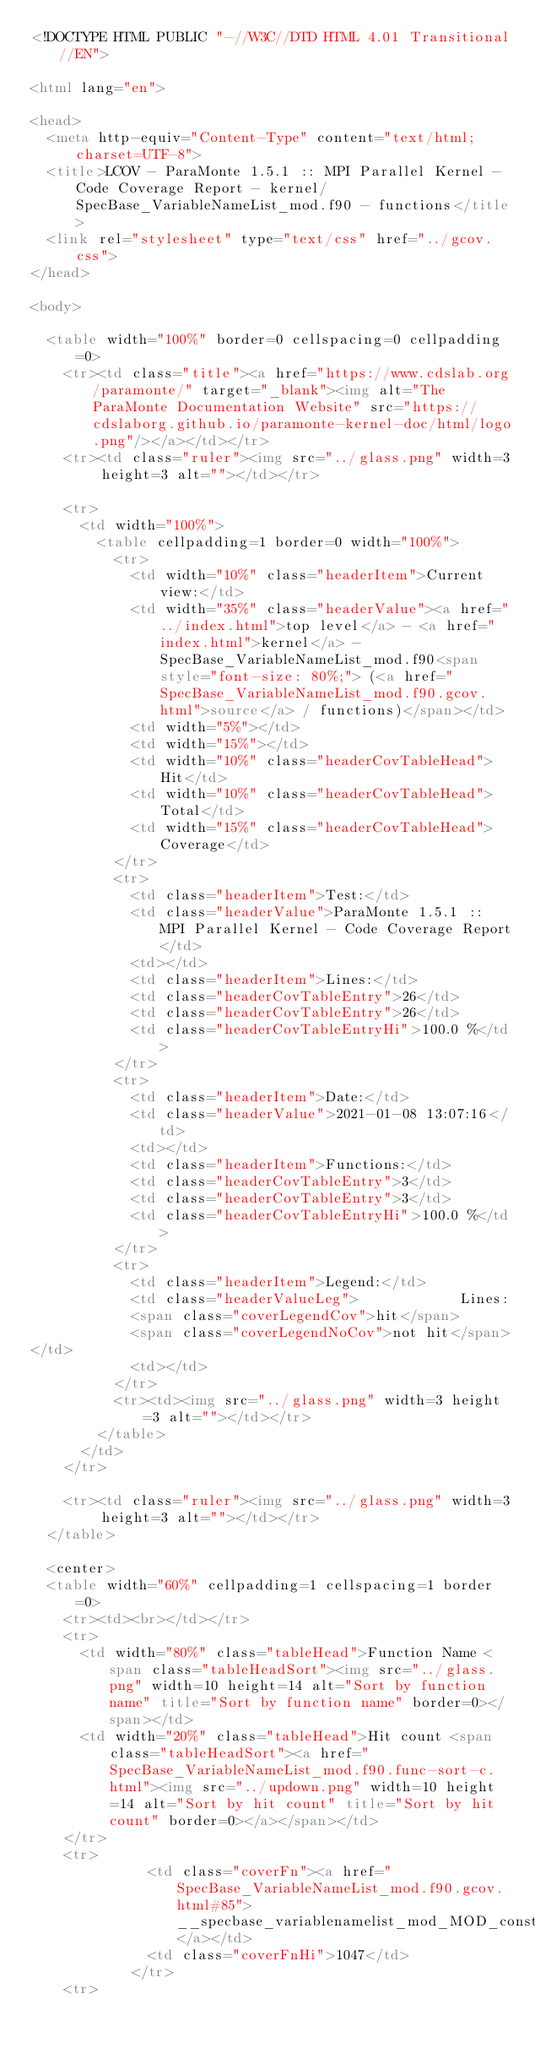<code> <loc_0><loc_0><loc_500><loc_500><_HTML_><!DOCTYPE HTML PUBLIC "-//W3C//DTD HTML 4.01 Transitional//EN">

<html lang="en">

<head>
  <meta http-equiv="Content-Type" content="text/html; charset=UTF-8">
  <title>LCOV - ParaMonte 1.5.1 :: MPI Parallel Kernel - Code Coverage Report - kernel/SpecBase_VariableNameList_mod.f90 - functions</title>
  <link rel="stylesheet" type="text/css" href="../gcov.css">
</head>

<body>

  <table width="100%" border=0 cellspacing=0 cellpadding=0>
    <tr><td class="title"><a href="https://www.cdslab.org/paramonte/" target="_blank"><img alt="The ParaMonte Documentation Website" src="https://cdslaborg.github.io/paramonte-kernel-doc/html/logo.png"/></a></td></tr>
    <tr><td class="ruler"><img src="../glass.png" width=3 height=3 alt=""></td></tr>

    <tr>
      <td width="100%">
        <table cellpadding=1 border=0 width="100%">
          <tr>
            <td width="10%" class="headerItem">Current view:</td>
            <td width="35%" class="headerValue"><a href="../index.html">top level</a> - <a href="index.html">kernel</a> - SpecBase_VariableNameList_mod.f90<span style="font-size: 80%;"> (<a href="SpecBase_VariableNameList_mod.f90.gcov.html">source</a> / functions)</span></td>
            <td width="5%"></td>
            <td width="15%"></td>
            <td width="10%" class="headerCovTableHead">Hit</td>
            <td width="10%" class="headerCovTableHead">Total</td>
            <td width="15%" class="headerCovTableHead">Coverage</td>
          </tr>
          <tr>
            <td class="headerItem">Test:</td>
            <td class="headerValue">ParaMonte 1.5.1 :: MPI Parallel Kernel - Code Coverage Report</td>
            <td></td>
            <td class="headerItem">Lines:</td>
            <td class="headerCovTableEntry">26</td>
            <td class="headerCovTableEntry">26</td>
            <td class="headerCovTableEntryHi">100.0 %</td>
          </tr>
          <tr>
            <td class="headerItem">Date:</td>
            <td class="headerValue">2021-01-08 13:07:16</td>
            <td></td>
            <td class="headerItem">Functions:</td>
            <td class="headerCovTableEntry">3</td>
            <td class="headerCovTableEntry">3</td>
            <td class="headerCovTableEntryHi">100.0 %</td>
          </tr>
          <tr>
            <td class="headerItem">Legend:</td>
            <td class="headerValueLeg">            Lines:
            <span class="coverLegendCov">hit</span>
            <span class="coverLegendNoCov">not hit</span>
</td>
            <td></td>
          </tr>
          <tr><td><img src="../glass.png" width=3 height=3 alt=""></td></tr>
        </table>
      </td>
    </tr>

    <tr><td class="ruler"><img src="../glass.png" width=3 height=3 alt=""></td></tr>
  </table>

  <center>
  <table width="60%" cellpadding=1 cellspacing=1 border=0>
    <tr><td><br></td></tr>
    <tr>
      <td width="80%" class="tableHead">Function Name <span class="tableHeadSort"><img src="../glass.png" width=10 height=14 alt="Sort by function name" title="Sort by function name" border=0></span></td>
      <td width="20%" class="tableHead">Hit count <span class="tableHeadSort"><a href="SpecBase_VariableNameList_mod.f90.func-sort-c.html"><img src="../updown.png" width=10 height=14 alt="Sort by hit count" title="Sort by hit count" border=0></a></span></td>
    </tr>
    <tr>
              <td class="coverFn"><a href="SpecBase_VariableNameList_mod.f90.gcov.html#85">__specbase_variablenamelist_mod_MOD_constructvariablenamelist</a></td>
              <td class="coverFnHi">1047</td>
            </tr>
    <tr></code> 